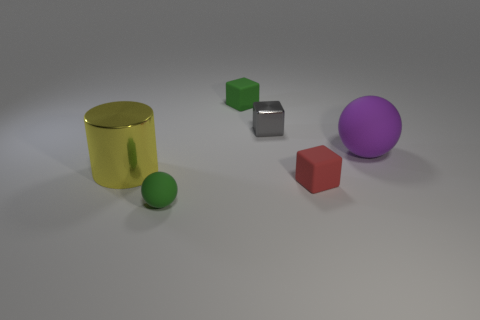Add 2 purple things. How many objects exist? 8 Subtract all spheres. How many objects are left? 4 Subtract all tiny green rubber cubes. Subtract all matte objects. How many objects are left? 1 Add 2 tiny red rubber things. How many tiny red rubber things are left? 3 Add 5 small brown cylinders. How many small brown cylinders exist? 5 Subtract 1 green spheres. How many objects are left? 5 